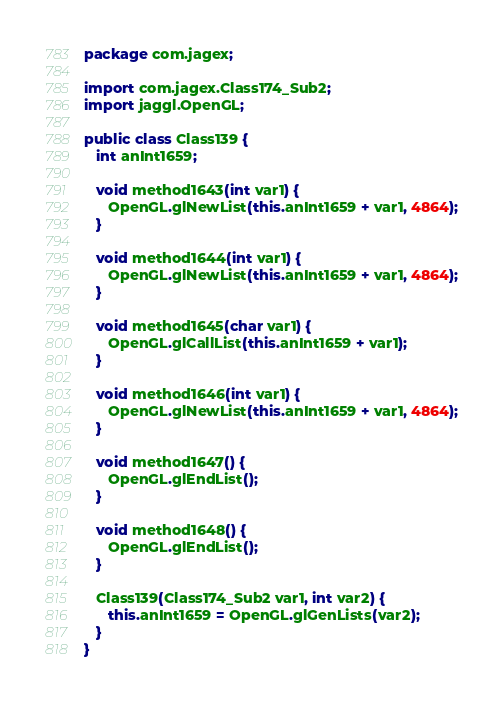Convert code to text. <code><loc_0><loc_0><loc_500><loc_500><_Java_>package com.jagex;

import com.jagex.Class174_Sub2;
import jaggl.OpenGL;

public class Class139 {
   int anInt1659;

   void method1643(int var1) {
      OpenGL.glNewList(this.anInt1659 + var1, 4864);
   }

   void method1644(int var1) {
      OpenGL.glNewList(this.anInt1659 + var1, 4864);
   }

   void method1645(char var1) {
      OpenGL.glCallList(this.anInt1659 + var1);
   }

   void method1646(int var1) {
      OpenGL.glNewList(this.anInt1659 + var1, 4864);
   }

   void method1647() {
      OpenGL.glEndList();
   }

   void method1648() {
      OpenGL.glEndList();
   }

   Class139(Class174_Sub2 var1, int var2) {
      this.anInt1659 = OpenGL.glGenLists(var2);
   }
}
</code> 